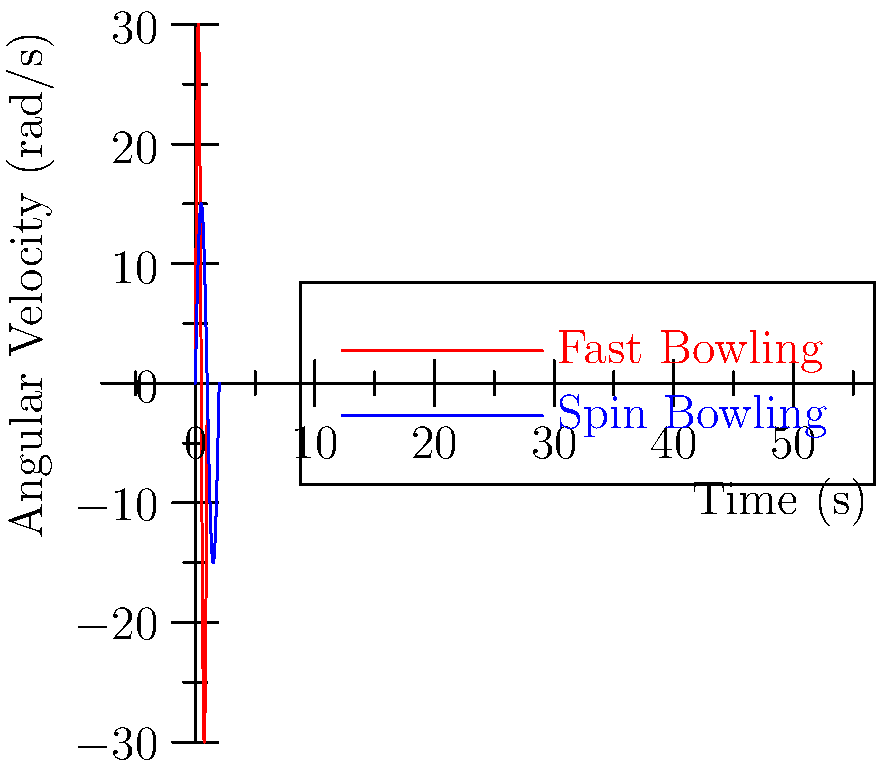In the graph above, which depicts the angular velocity of the bowling arm over time for fast and spin bowling techniques, what key biomechanical difference can be observed between the two styles, and how might this relate to the Kapu community's traditional farming practices? To answer this question, let's analyze the graph step-by-step:

1. The red curve represents fast bowling, while the blue curve represents spin bowling.

2. Fast bowling (red curve):
   - Higher peak angular velocity (approximately 30 rad/s)
   - Shorter duration (completes in about 0.5 seconds)

3. Spin bowling (blue curve):
   - Lower peak angular velocity (approximately 15 rad/s)
   - Longer duration (completes in about 2 seconds)

4. Key biomechanical difference:
   Fast bowling involves a quicker, more explosive arm motion with higher angular velocity, while spin bowling uses a slower, more controlled arm motion with lower angular velocity.

5. Relation to Kapu community's traditional farming practices:
   The Kapu community, traditionally involved in agriculture, might relate this difference to various farming tasks:
   - Fast bowling motion: Similar to quick, forceful movements like harvesting with a sickle or throwing seeds during sowing.
   - Spin bowling motion: Comparable to more controlled, precise movements like careful crop inspection or delicate handling of produce.

This comparison allows for a cultural connection between cricket biomechanics and traditional agricultural practices, making the concept more relatable to the Indian history professor from the Kapu community.
Answer: Fast bowling has higher peak angular velocity and shorter duration compared to spin bowling, reflecting explosive vs. controlled arm motions similar to different agricultural tasks in Kapu farming tradition. 